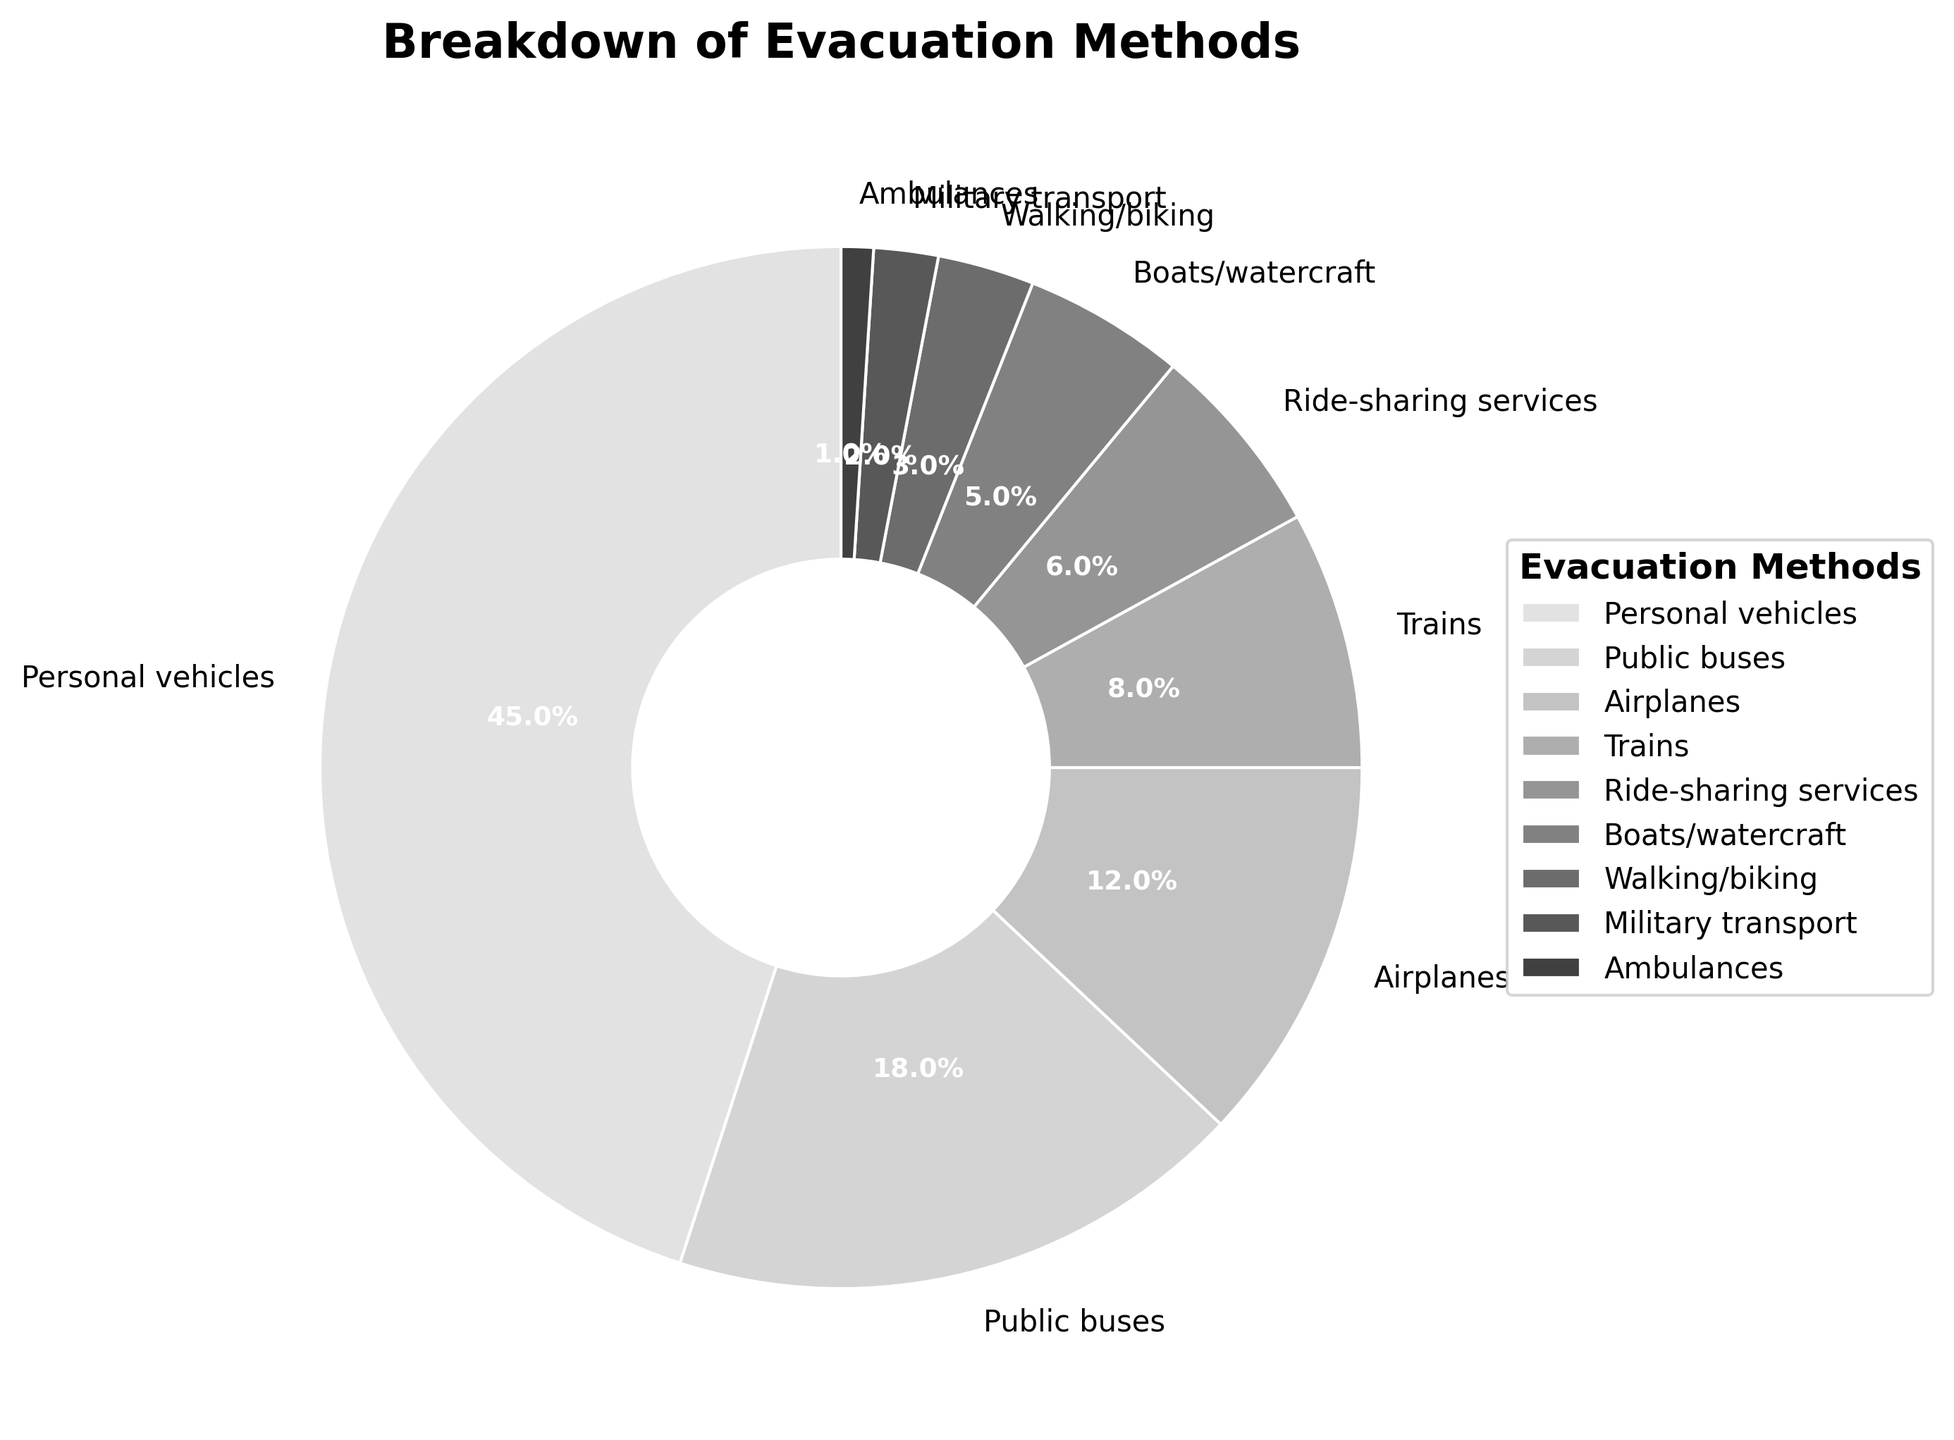What method was used by the majority of the affected population? The method occupying the largest section of the pie chart is labeled "Personal vehicles" with a percentage of 45%.
Answer: Personal vehicles What is the combined percentage of populations using ride-sharing services, boats/watercraft, walking/biking, and military transport? Adding the percentages for Ride-sharing services (6%), Boats/watercraft (5%), Walking/biking (3%), and Military transport (2%) gives 6 + 5 + 3 + 2 = 16%.
Answer: 16% Which evacuation method was used by fewer people than public buses but more than ride-sharing services? The pie chart shows that Airplanes were used by 12% of the population, which is fewer than Public buses (18%) but more than Ride-sharing services (6%).
Answer: Airplanes What is the percentage difference between the use of personal vehicles and trains? The percentage use of Personal vehicles is 45%, and the percentage use of Trains is 8%. The difference is 45 - 8 = 37%.
Answer: 37% Which method has the smallest percentage of use, and what is that percentage? The smallest section of the pie chart is labeled "Ambulances," with a percentage of 1%.
Answer: Ambulances, 1% How does the use of public buses compare to the combined use of trains and airplanes? Public buses account for 18%. Trains account for 8% and Airplanes for 12%. The total for Trains and Airplanes is 8 + 12 = 20%, which is higher than the 18% for Public buses.
Answer: Trains and Airplanes combined > Public buses Is the percentage of people using walking/biking greater than those using boats/watercraft? The pie chart shows that Walking/biking was used by 3%, while Boats/watercraft were used by 5%, meaning Boats/watercraft is greater than Walking/biking.
Answer: No What is the total percentage of people using personal vehicles, public buses, and airplanes? Adding the percentages for Personal vehicles (45%), Public buses (18%), and Airplanes (12%) gives 45 + 18 + 12 = 75%.
Answer: 75% What is the percentage gap between the most used and the least used evacuation method? The most used method is Personal vehicles (45%), and the least used is Ambulances (1%). The gap is 45 - 1 = 44%.
Answer: 44% How many methods were used by less than 10% of the population each? Methods with less than 10% are Trains (8%), Ride-sharing services (6%), Boats/watercraft (5%), Walking/biking (3%), Military transport (2%), and Ambulances (1%). There are 6 such methods.
Answer: 6 